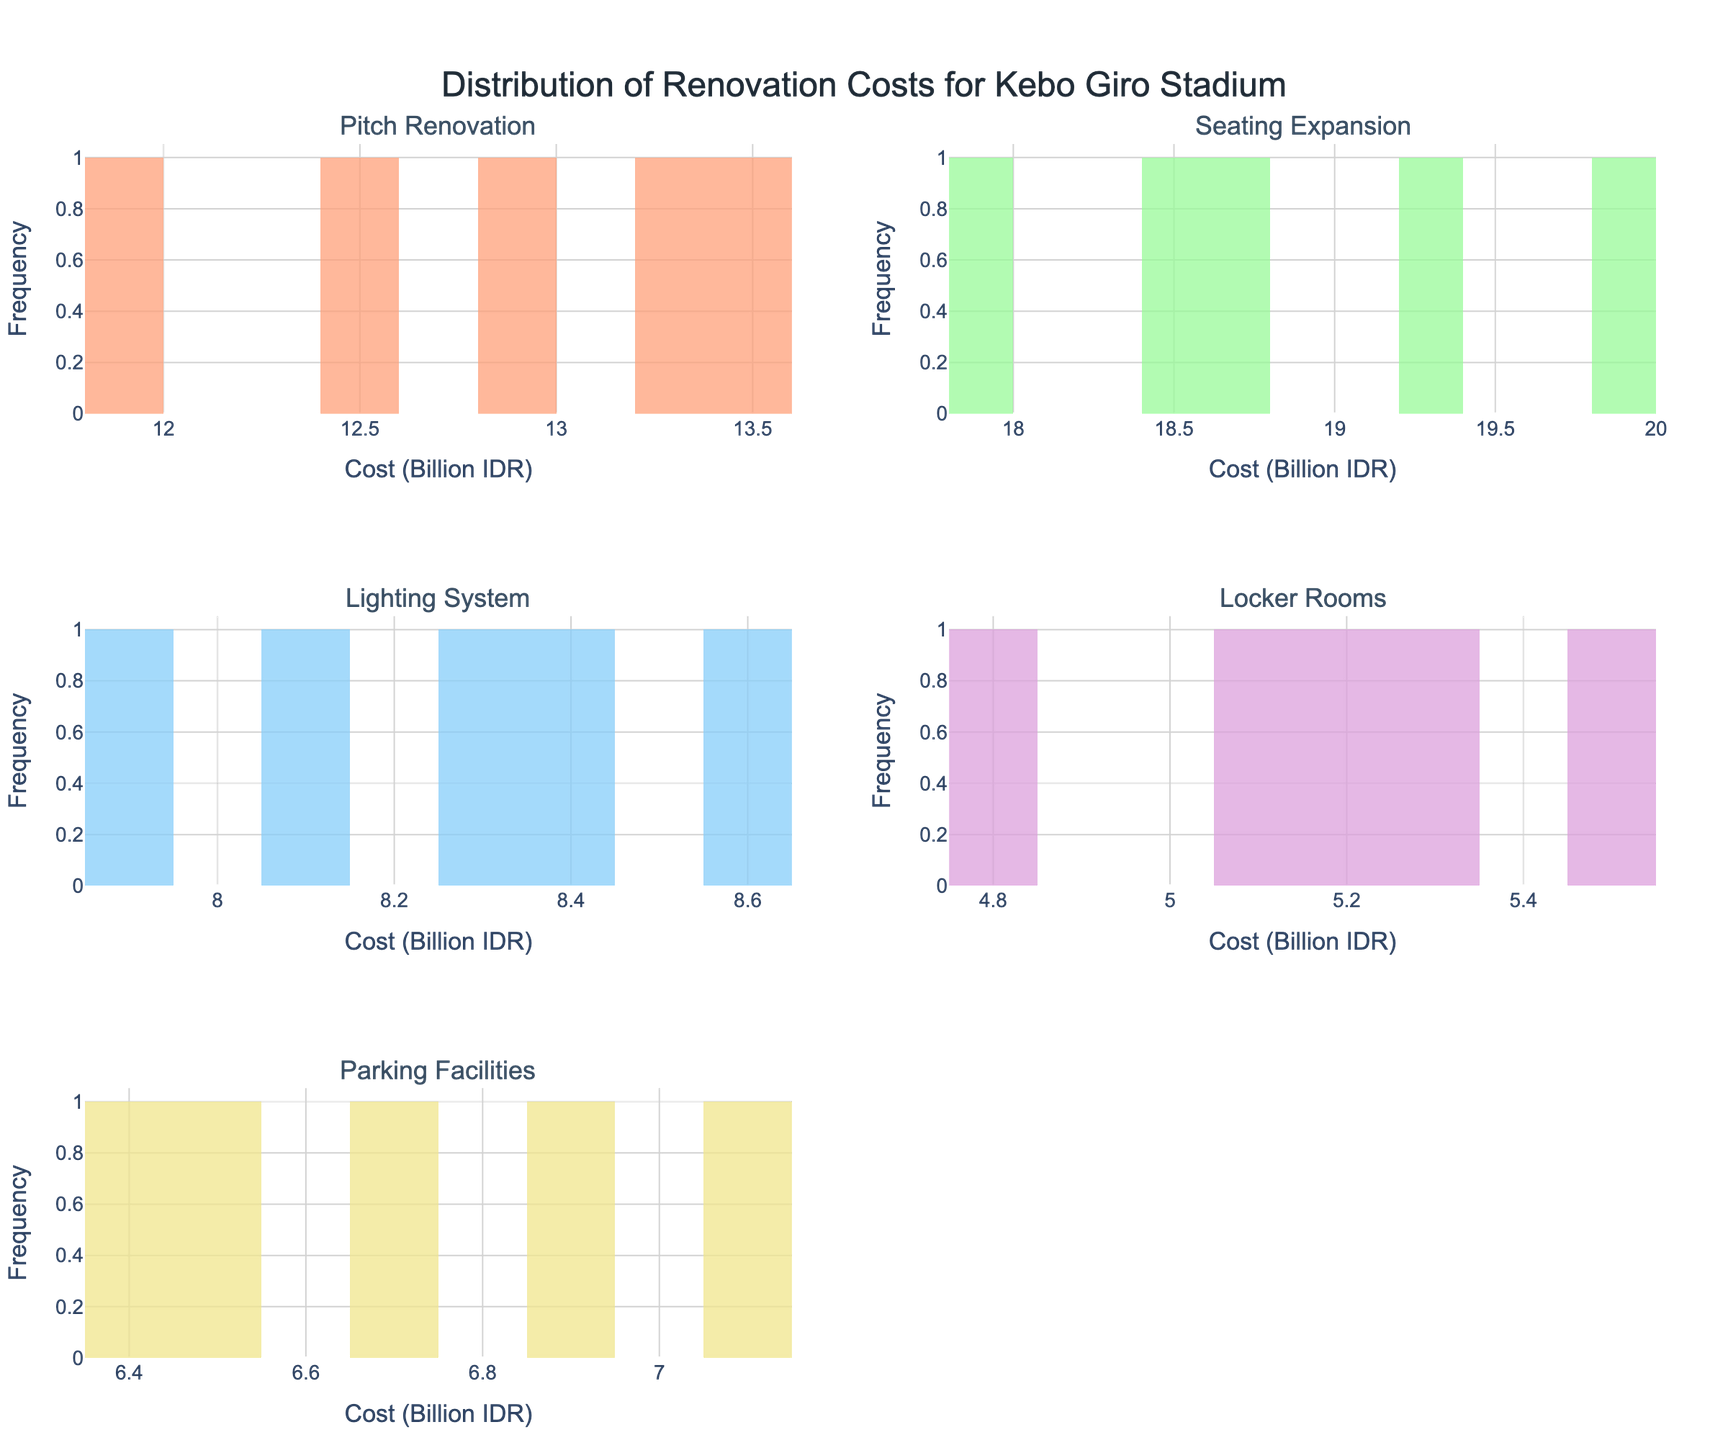What is the total number of improvement categories presented in the figure? There are five unique improvement categories listed in the figure: Pitch Renovation, Seating Expansion, Lighting System, Locker Rooms, and Parking Facilities.
Answer: Five Which improvement category appears to have the highest renovation costs? By looking at the histograms, the Seating Expansion category has the highest renovation costs, evident from its position on the x-axis with values ranging between 17.9 and 19.8 Billion IDR.
Answer: Seating Expansion What is the range of renovation costs for the Pitch Renovation category? The Pitch Renovation histogram shows values ranging from 11.8 to 13.5 Billion IDR, so the range can be calculated as 13.5 - 11.8.
Answer: 1.7 Billion IDR Which category has the narrowest range of renovation costs? Comparing the width of the histograms, the Lighting System category appears to have the narrowest range, with costs varying from 7.9 to 8.6 Billion IDR.
Answer: Lighting System What is the median renovation cost for the Lighting System category? To find the median, first list the values: 7.9, 8.1, 8.3, 8.4, 8.6. The middle value is 8.3.
Answer: 8.3 Billion IDR Which improvement category shows the greatest variability in renovation costs? By observing the spread and width of the histograms, the Seating Expansion category shows the greatest variability, with costs ranging from 17.9 to 19.8 Billion IDR.
Answer: Seating Expansion What is the difference between the highest and lowest renovation costs in the Parking Facilities category? The highest cost in the Parking Facilities category is 7.1 Billion IDR, and the lowest is 6.4 Billion IDR. The difference is 7.1 - 6.4.
Answer: 0.7 Billion IDR Between Locker Rooms and Lighting System, which category has more uniform renovation costs? The histograms show that the Lighting System has more uniform costs, with a tighter spread between 7.9 and 8.6 Billion IDR, compared to Locker Rooms.
Answer: Lighting System How many renovation cost data points are there in the Parking Facilities category? The histogram for Parking Facilities includes five bars, each representing a data point, so there are five data points.
Answer: Five 